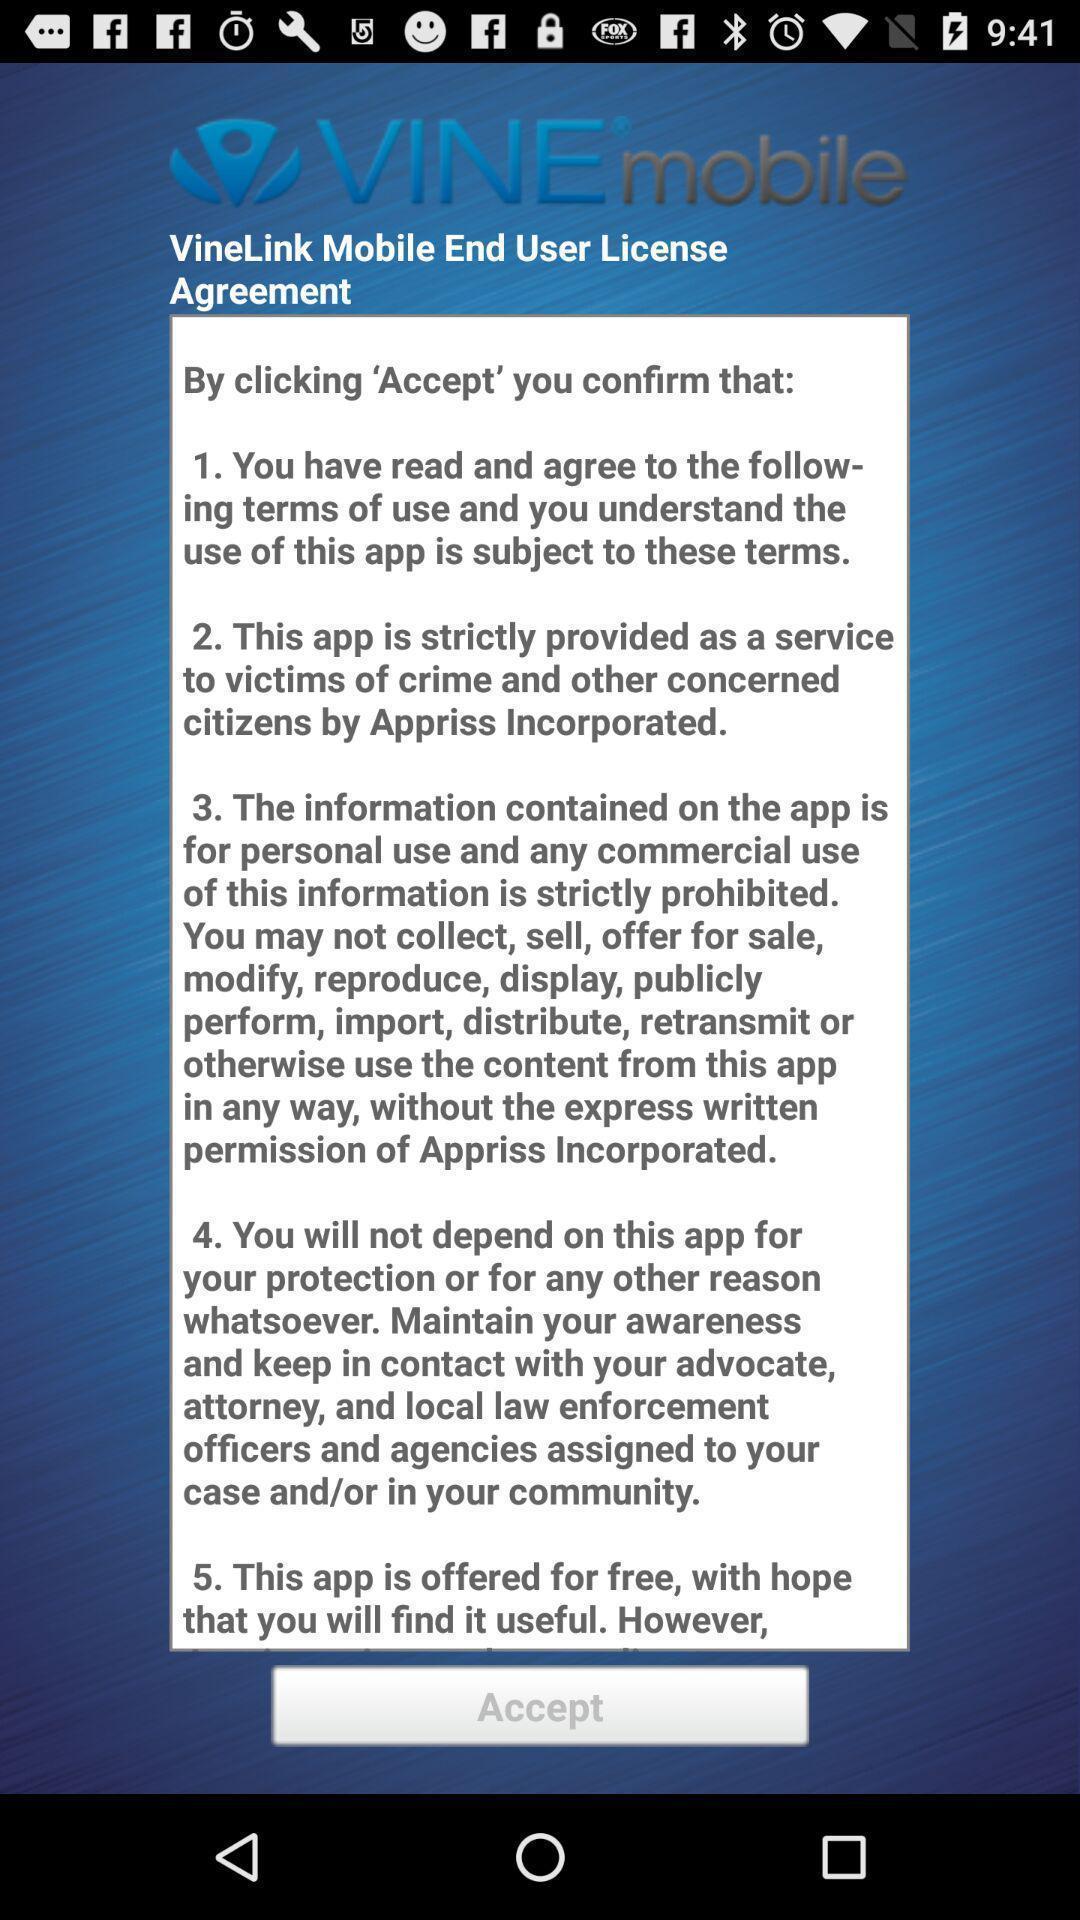Tell me about the visual elements in this screen capture. Screen shows agreement details. 